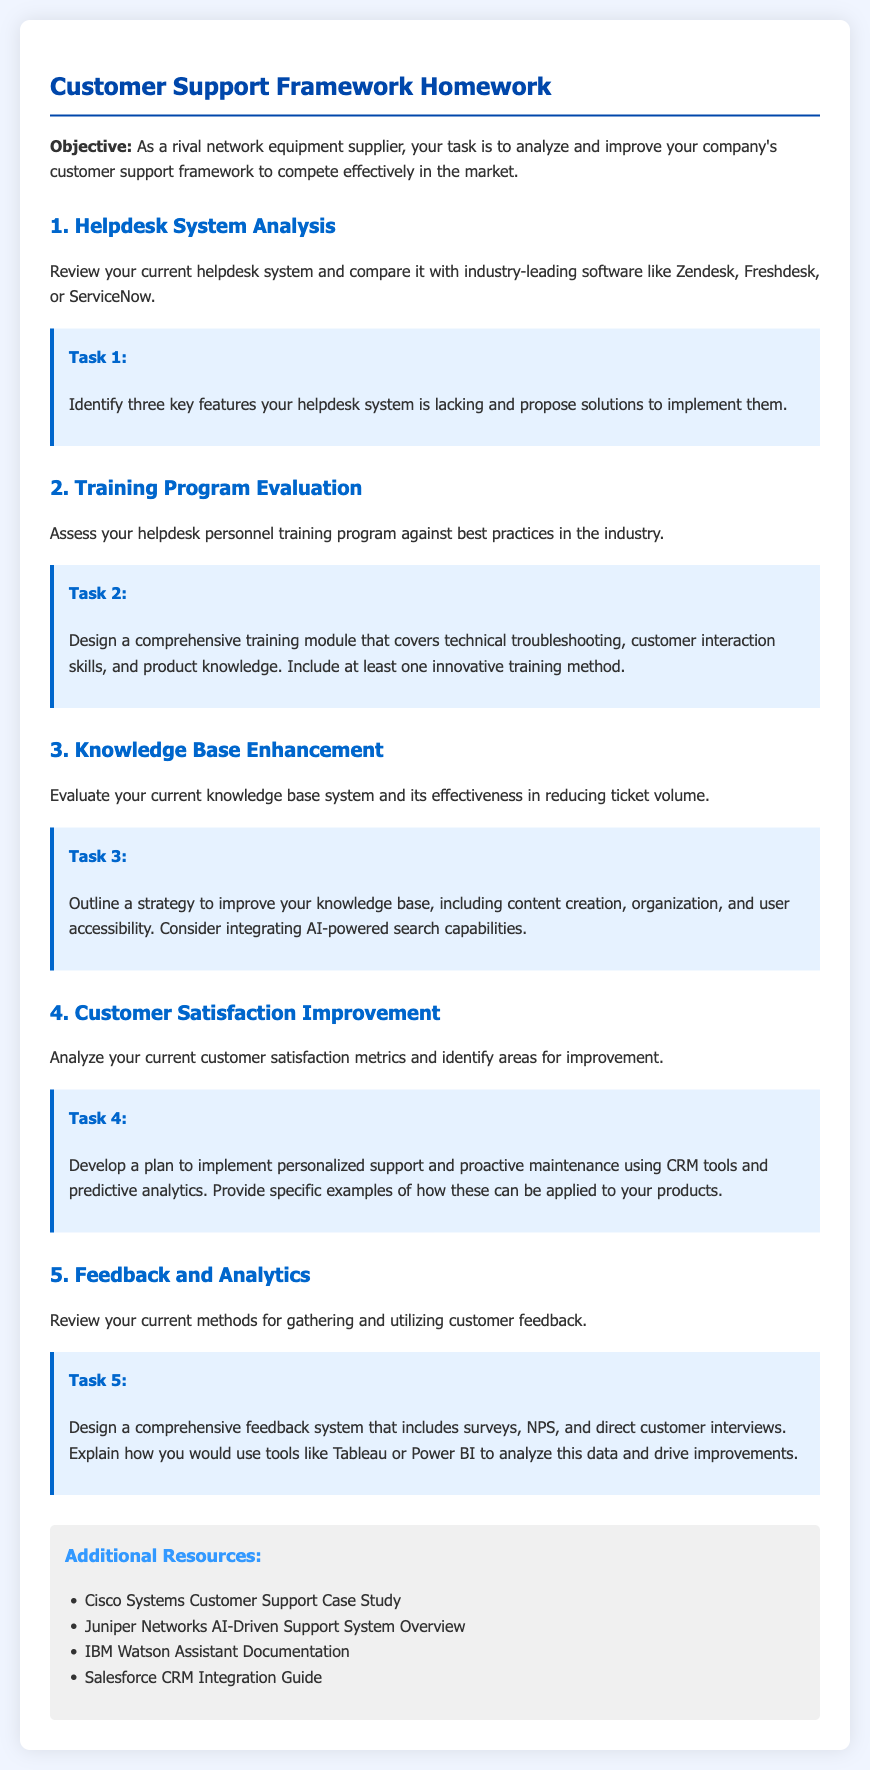What is the title of the homework? The title of the homework is stated at the top of the document, which is "Customer Support Framework Homework."
Answer: Customer Support Framework Homework What is the objective of the homework? The objective is mentioned in the introduction section as a task to analyze and improve the customer support framework to compete effectively in the market.
Answer: Analyze and improve company’s customer support framework How many tasks are included in the document? The number of tasks can be counted in the document under the numbered sections. There are five distinct tasks listed.
Answer: 5 What is Task 1 focused on? Task 1 focuses on reviewing the current helpdesk system and identifying features that are lacking.
Answer: Helpdesk system analysis What should be included in the training module for Task 2? The training module should include technical troubleshooting, customer interaction skills, and product knowledge.
Answer: Technical troubleshooting, customer interaction skills, and product knowledge Which tools are suggested for analyzing customer feedback data in Task 5? The tools suggested for analyzing data in Task 5 include Tableau and Power BI.
Answer: Tableau and Power BI What does the resources section provide? The resources section provides additional materials that can aid in customer support framework analysis.
Answer: Additional Resources What is one innovative training method mentioned for Task 2? The document specifies that an innovative training method should be included in the comprehensive training module design.
Answer: Innovative training method What should the strategy to improve the knowledge base include in Task 3? The strategy for improving the knowledge base includes content creation, organization, and user accessibility.
Answer: Content creation, organization, and user accessibility 